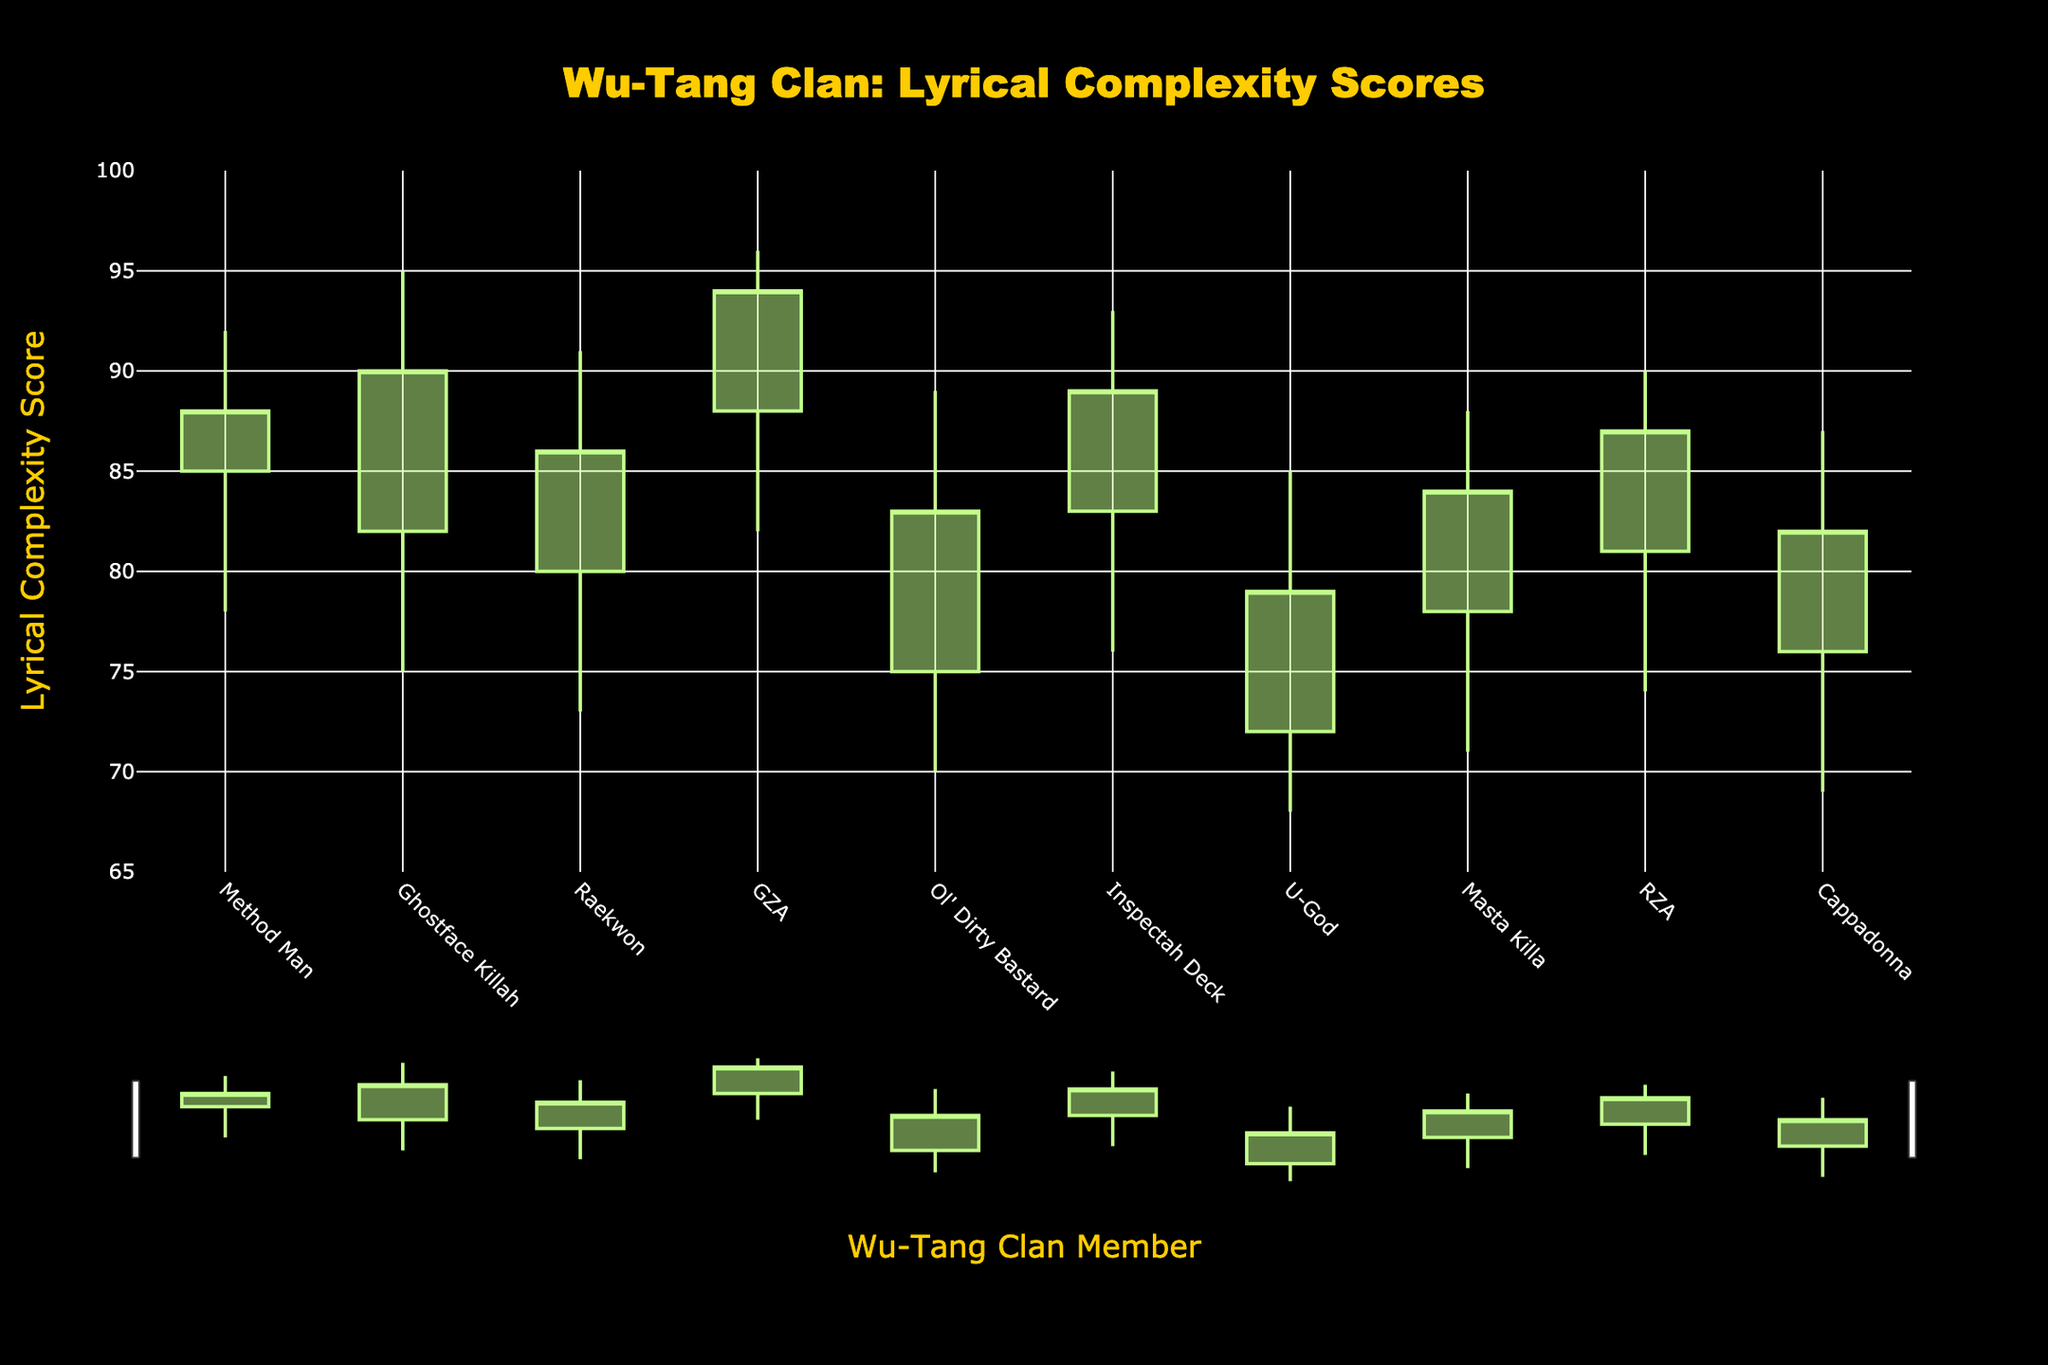What is the title of the chart? The title of the chart is usually displayed prominently at the top. In this case, it reads "Wu-Tang Clan: Lyrical Complexity Scores".
Answer: Wu-Tang Clan: Lyrical Complexity Scores Which member has the highest closing score? To find the highest closing score, look for the tallest bar ending. GZA has the highest closing score of 94.
Answer: GZA How many members have an opening score above 80? Count the number of members whose opening score is above 80 by looking at the initial values on the chart. These members are Method Man, Ghostface Killah, Raekwon, GZA, Inspectah Deck, and RZA, totaling 6.
Answer: 6 Which member shows the greatest range in lyrical complexity score? The range is calculated as the difference between the highest and lowest points. Compare the ranges across all members. Ghostface Killah has the highest range from 95 to 75, making the range 20.
Answer: Ghostface Killah Is there any member whose closing score is higher than their opening score, and if so, who? To answer this, identify members whose closing score bar ends higher than where the opening score bar begins. These members are Method Man, Ghostface Killah, Raekwon, GZA, Inspectah Deck, Masta Killa, and RZA.
Answer: Yes, multiple members How does Ol' Dirty Bastard's lowest score compare to U-God's lowest score? Check the lowest score values for both members. Ol' Dirty Bastard's lowest score is 70, while U-God's lowest score is 68. Therefore, Ol' Dirty Bastard's lowest score is 2 points higher than U-God's.
Answer: 2 points higher Which member(s) have a higher highest score than Method Man? Compare the highest scores of all members against Method Man's highest score of 92. Ghostface Killah and GZA have higher scores, with 95 and 96 respectively.
Answer: Ghostface Killah, GZA For which members is the closing score the same as the highest score? Identify the members for whom the closing score bar reaches the same height as the highest point. GZA is the only member for whom this is the case, with both scores at 94.
Answer: GZA What is the average opening score for all the members? Add up all the opening scores and divide by the number of members: (85+82+80+88+75+83+72+78+81+76)/10 = 80
Answer: 80 How many members have a lowest score below 75? Count the members with a low value below 75. The members are Ghostface Killah, Raekwon, Ol' Dirty Bastard, Inspectah Deck, U-God, Masta Killa, RZA, and Cappadonna, totaling 8 members.
Answer: 8 